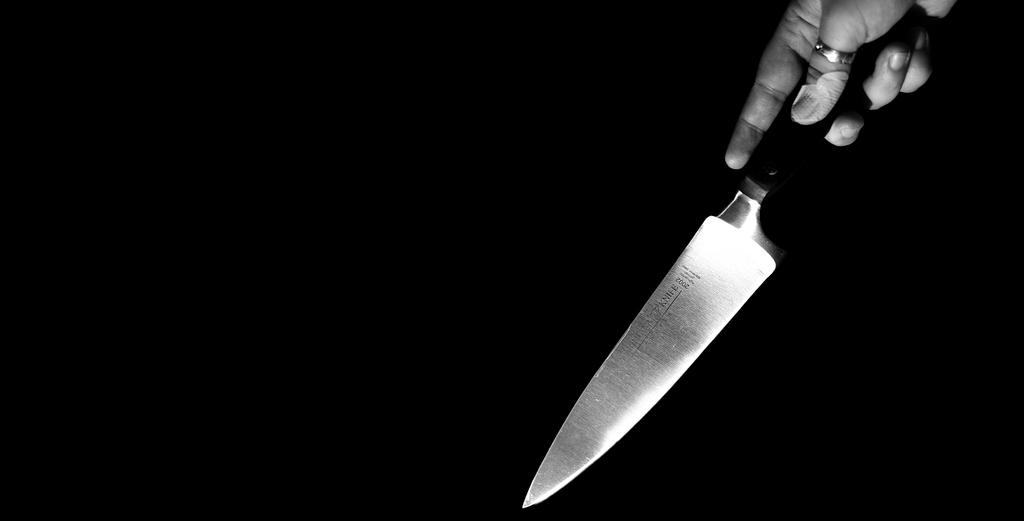What is the color scheme of the image? The image is black and white. What can be seen in the person's hand in the image? There is a knife being held by a person's hand in the image. How would you describe the overall lighting or brightness of the image? The background of the image is dark. What type of soda is being poured into the glass in the image? There is no glass or soda present in the image; it only features a person's hand holding a knife. What is the person's mind thinking while holding the knife in the image? The image does not provide any information about the person's thoughts or intentions, so we cannot determine what they are thinking. 